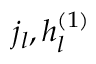Convert formula to latex. <formula><loc_0><loc_0><loc_500><loc_500>j _ { l } , h _ { l } ^ { ( 1 ) }</formula> 